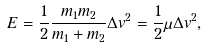<formula> <loc_0><loc_0><loc_500><loc_500>E = \frac { 1 } { 2 } \frac { m _ { 1 } m _ { 2 } } { m _ { 1 } + m _ { 2 } } \Delta v ^ { 2 } = \frac { 1 } { 2 } \mu \Delta v ^ { 2 } ,</formula> 